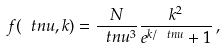<formula> <loc_0><loc_0><loc_500><loc_500>f ( \ t n u , k ) = \frac { N } { \ t n u ^ { 3 } } \frac { k ^ { 2 } } { e ^ { k / \ t n u } + 1 } \, ,</formula> 